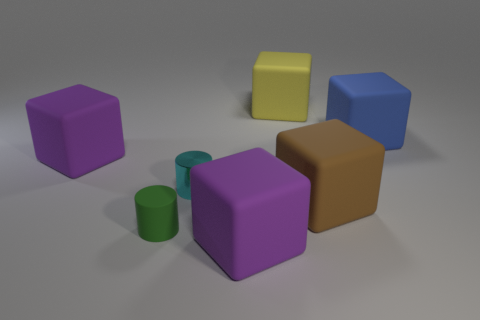Subtract all blue matte cubes. How many cubes are left? 4 Subtract all yellow cubes. How many cubes are left? 4 Subtract 1 blocks. How many blocks are left? 4 Subtract all cyan cubes. Subtract all blue cylinders. How many cubes are left? 5 Add 1 large red things. How many objects exist? 8 Subtract all blocks. How many objects are left? 2 Add 3 large blue cubes. How many large blue cubes exist? 4 Subtract 1 cyan cylinders. How many objects are left? 6 Subtract all green matte cylinders. Subtract all brown things. How many objects are left? 5 Add 4 yellow rubber objects. How many yellow rubber objects are left? 5 